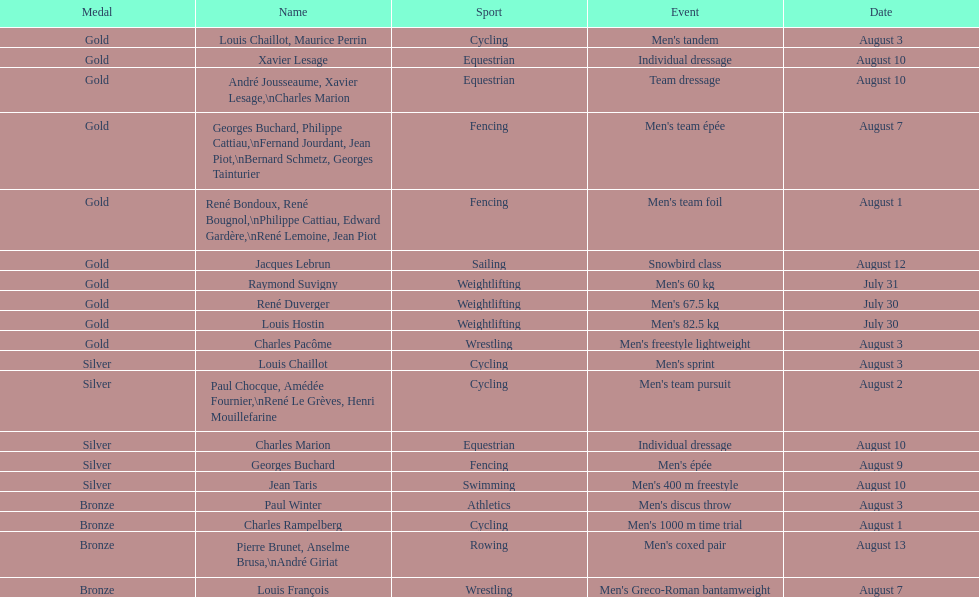What sport is listed first? Cycling. 